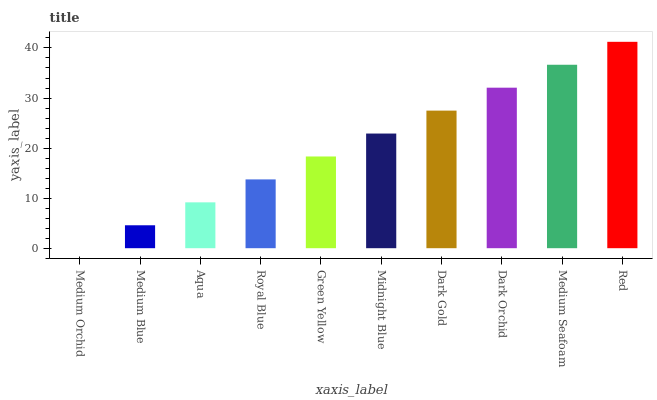Is Medium Orchid the minimum?
Answer yes or no. Yes. Is Red the maximum?
Answer yes or no. Yes. Is Medium Blue the minimum?
Answer yes or no. No. Is Medium Blue the maximum?
Answer yes or no. No. Is Medium Blue greater than Medium Orchid?
Answer yes or no. Yes. Is Medium Orchid less than Medium Blue?
Answer yes or no. Yes. Is Medium Orchid greater than Medium Blue?
Answer yes or no. No. Is Medium Blue less than Medium Orchid?
Answer yes or no. No. Is Midnight Blue the high median?
Answer yes or no. Yes. Is Green Yellow the low median?
Answer yes or no. Yes. Is Red the high median?
Answer yes or no. No. Is Medium Seafoam the low median?
Answer yes or no. No. 